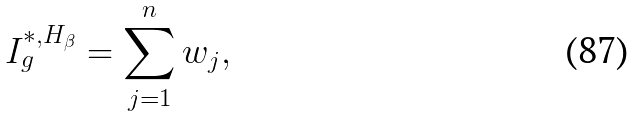<formula> <loc_0><loc_0><loc_500><loc_500>I _ { g } ^ { * , H _ { \beta } } = \sum _ { j = 1 } ^ { n } w _ { j } ,</formula> 